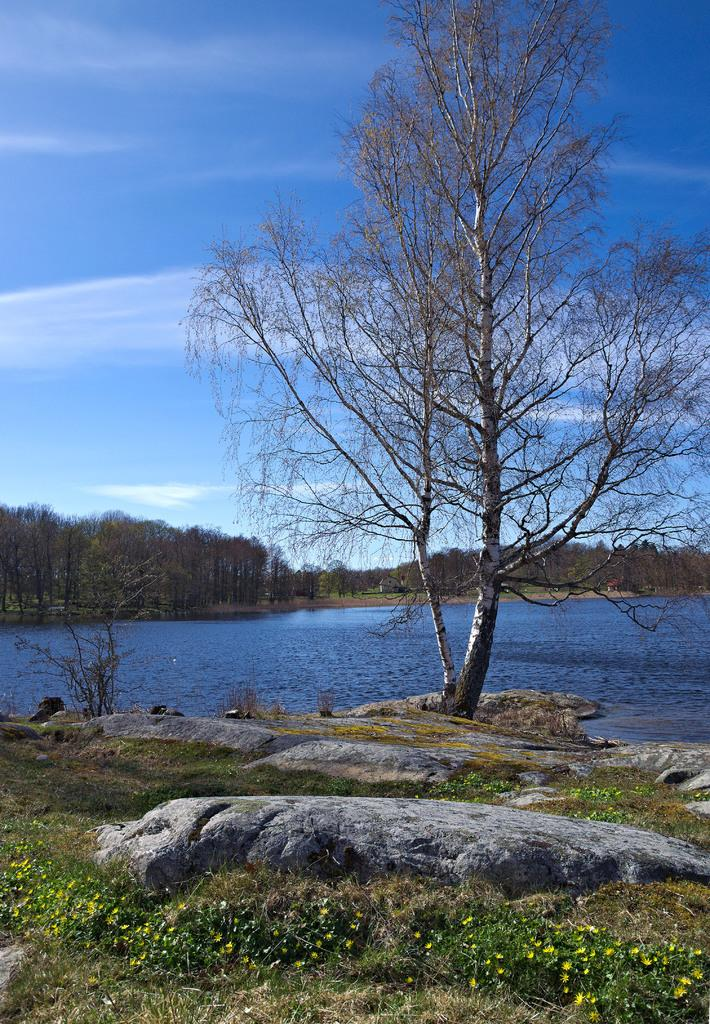What type of vegetation can be seen on the right side of the image? There is a tree on the right side of the image. What is located in the center of the image? There is water in the center of the image. What type of natural features are present in the image? There are rocks in the image. What type of ground is visible at the bottom side of the image? There is grass land at the bottom side of the image. Is the area in the image known for its quiet atmosphere? The provided facts do not mention anything about the noise level or atmosphere in the image, so it cannot be determined from the image alone. Can you see any writing on the rocks in the image? There is no mention of writing on the rocks in the image, so it cannot be determined from the image alone. 